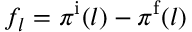Convert formula to latex. <formula><loc_0><loc_0><loc_500><loc_500>f _ { l } = \pi ^ { \mathrm i } ( l ) - \pi ^ { \mathrm f } ( l )</formula> 